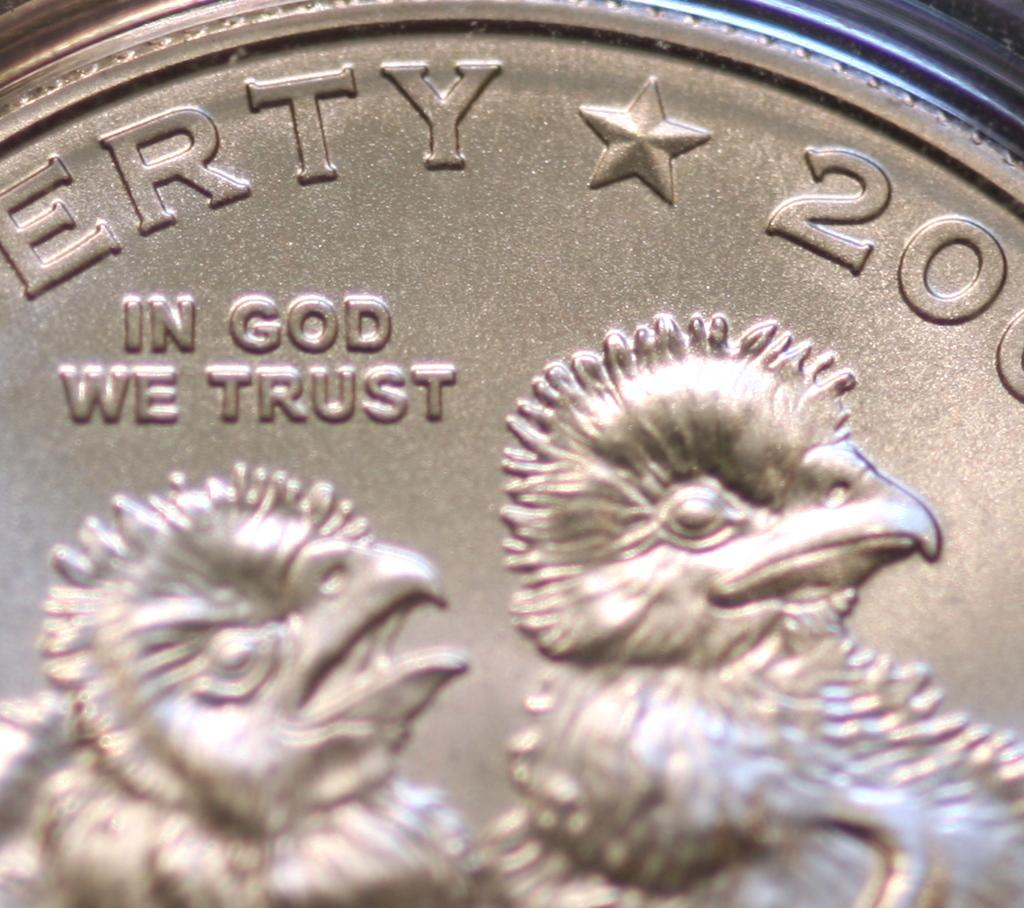Provide a one-sentence caption for the provided image. a close up of a coin with two chicks reading In God We Trust. 